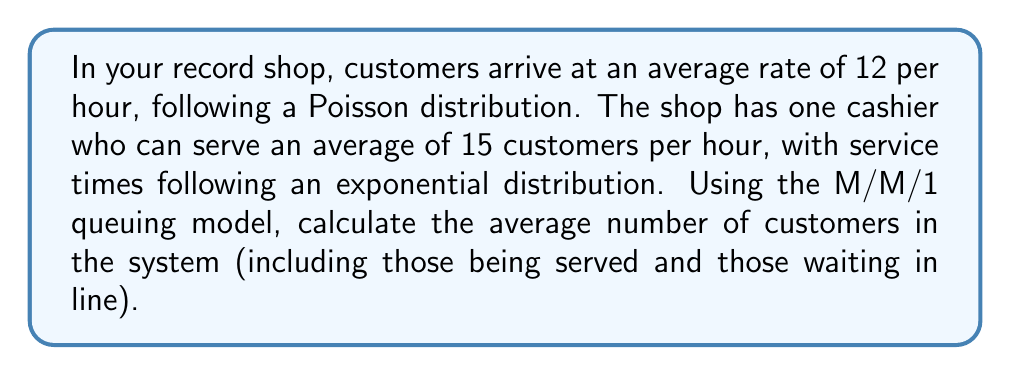Show me your answer to this math problem. To solve this problem, we'll use the M/M/1 queuing model, which is appropriate for a single-server system with Poisson arrivals and exponential service times.

Step 1: Identify the parameters
- Arrival rate (λ) = 12 customers/hour
- Service rate (μ) = 15 customers/hour

Step 2: Calculate the utilization factor (ρ)
The utilization factor is given by:
$$\rho = \frac{\lambda}{\mu}$$

$$\rho = \frac{12}{15} = 0.8$$

Step 3: Calculate the average number of customers in the system (L)
For an M/M/1 queue, the average number of customers in the system is given by:
$$L = \frac{\rho}{1 - \rho}$$

Substituting our calculated ρ:
$$L = \frac{0.8}{1 - 0.8} = \frac{0.8}{0.2} = 4$$

Therefore, the average number of customers in the system is 4.
Answer: 4 customers 